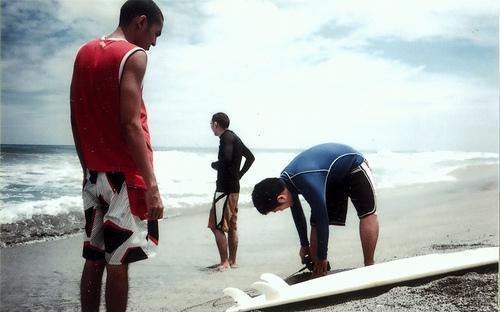How many surfboards are in the picture?
Give a very brief answer. 1. 